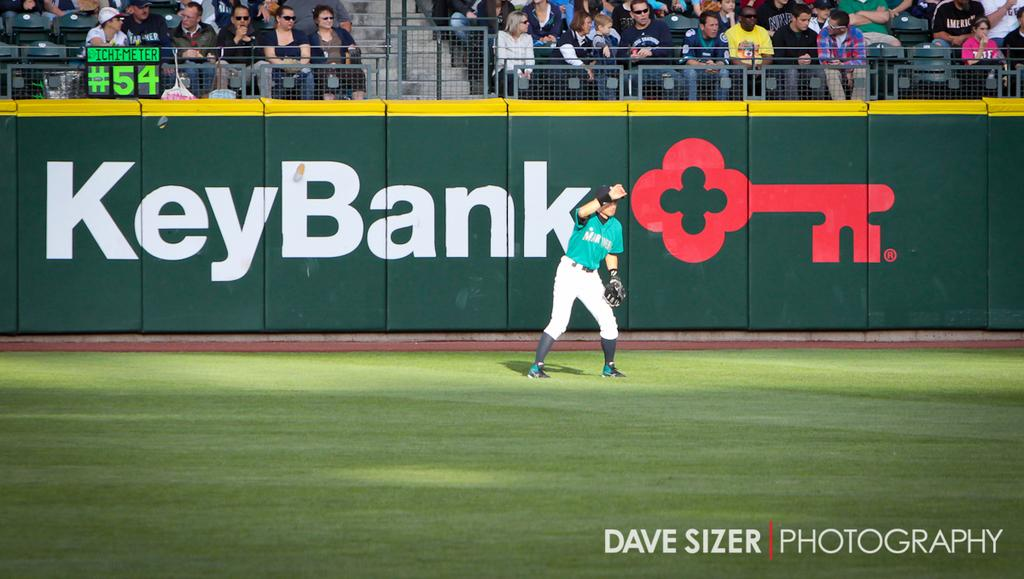<image>
Relay a brief, clear account of the picture shown. The outfield of a baseball stadium has an advertisement for KeyBank. 